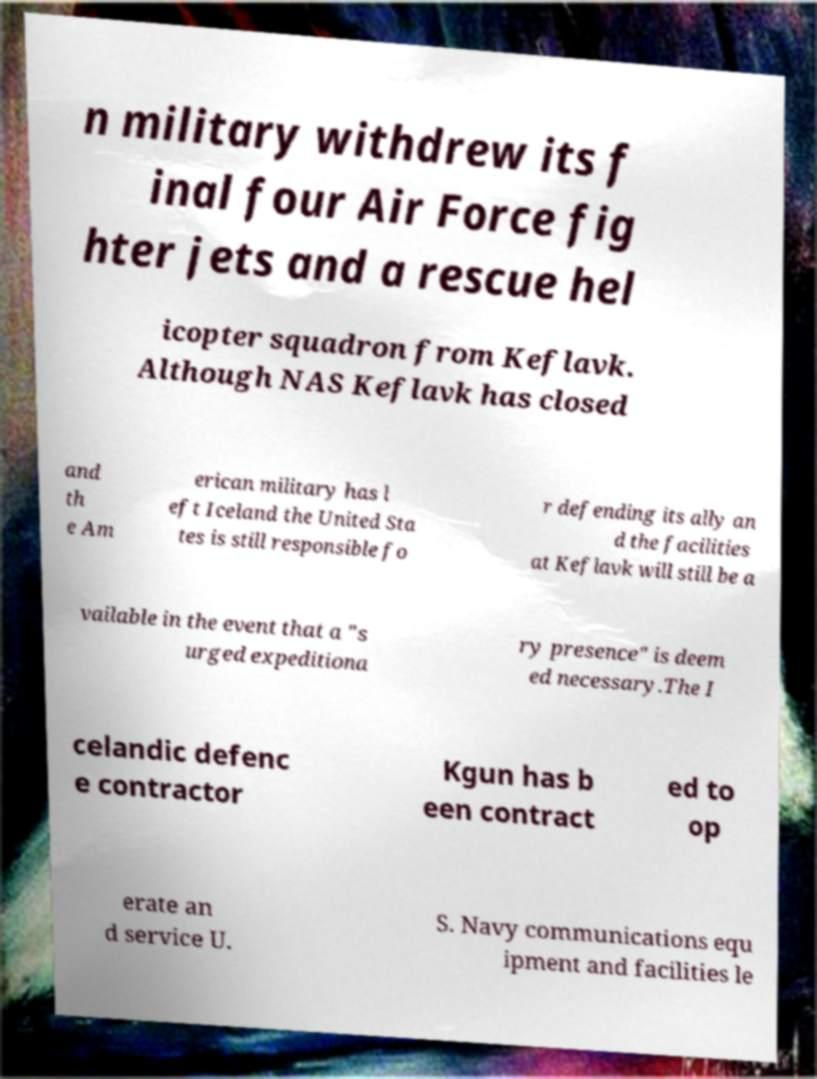Please read and relay the text visible in this image. What does it say? n military withdrew its f inal four Air Force fig hter jets and a rescue hel icopter squadron from Keflavk. Although NAS Keflavk has closed and th e Am erican military has l eft Iceland the United Sta tes is still responsible fo r defending its ally an d the facilities at Keflavk will still be a vailable in the event that a "s urged expeditiona ry presence" is deem ed necessary.The I celandic defenc e contractor Kgun has b een contract ed to op erate an d service U. S. Navy communications equ ipment and facilities le 